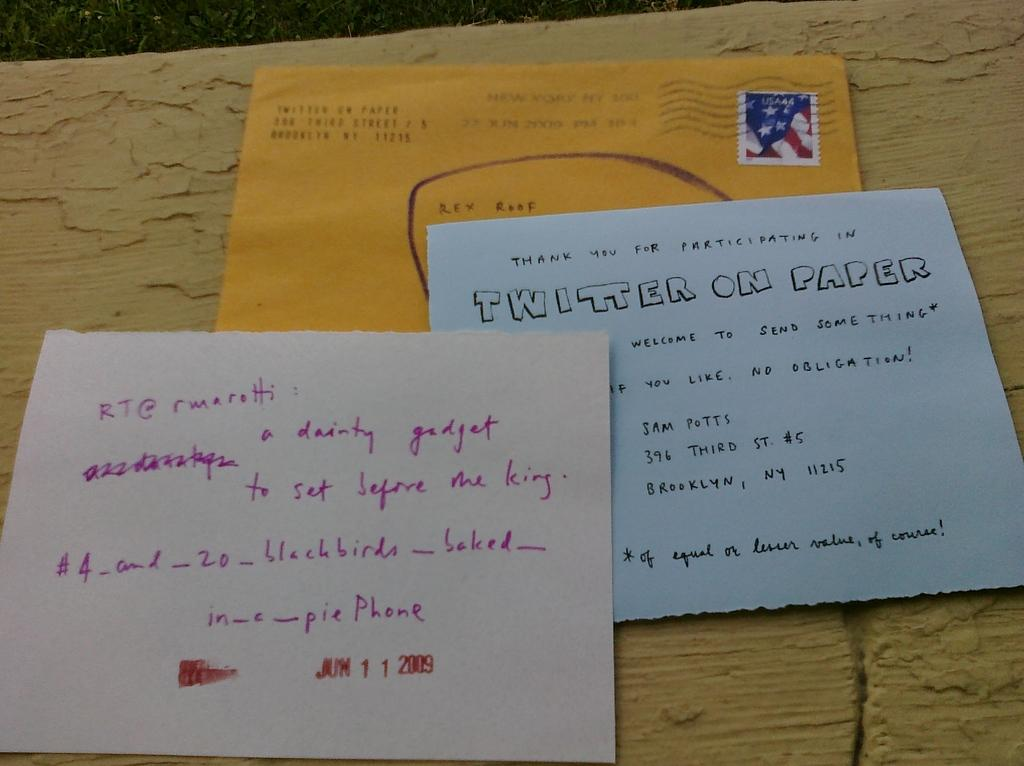<image>
Provide a brief description of the given image. A yellow envelop above a card that reads Twitter on Paper. 